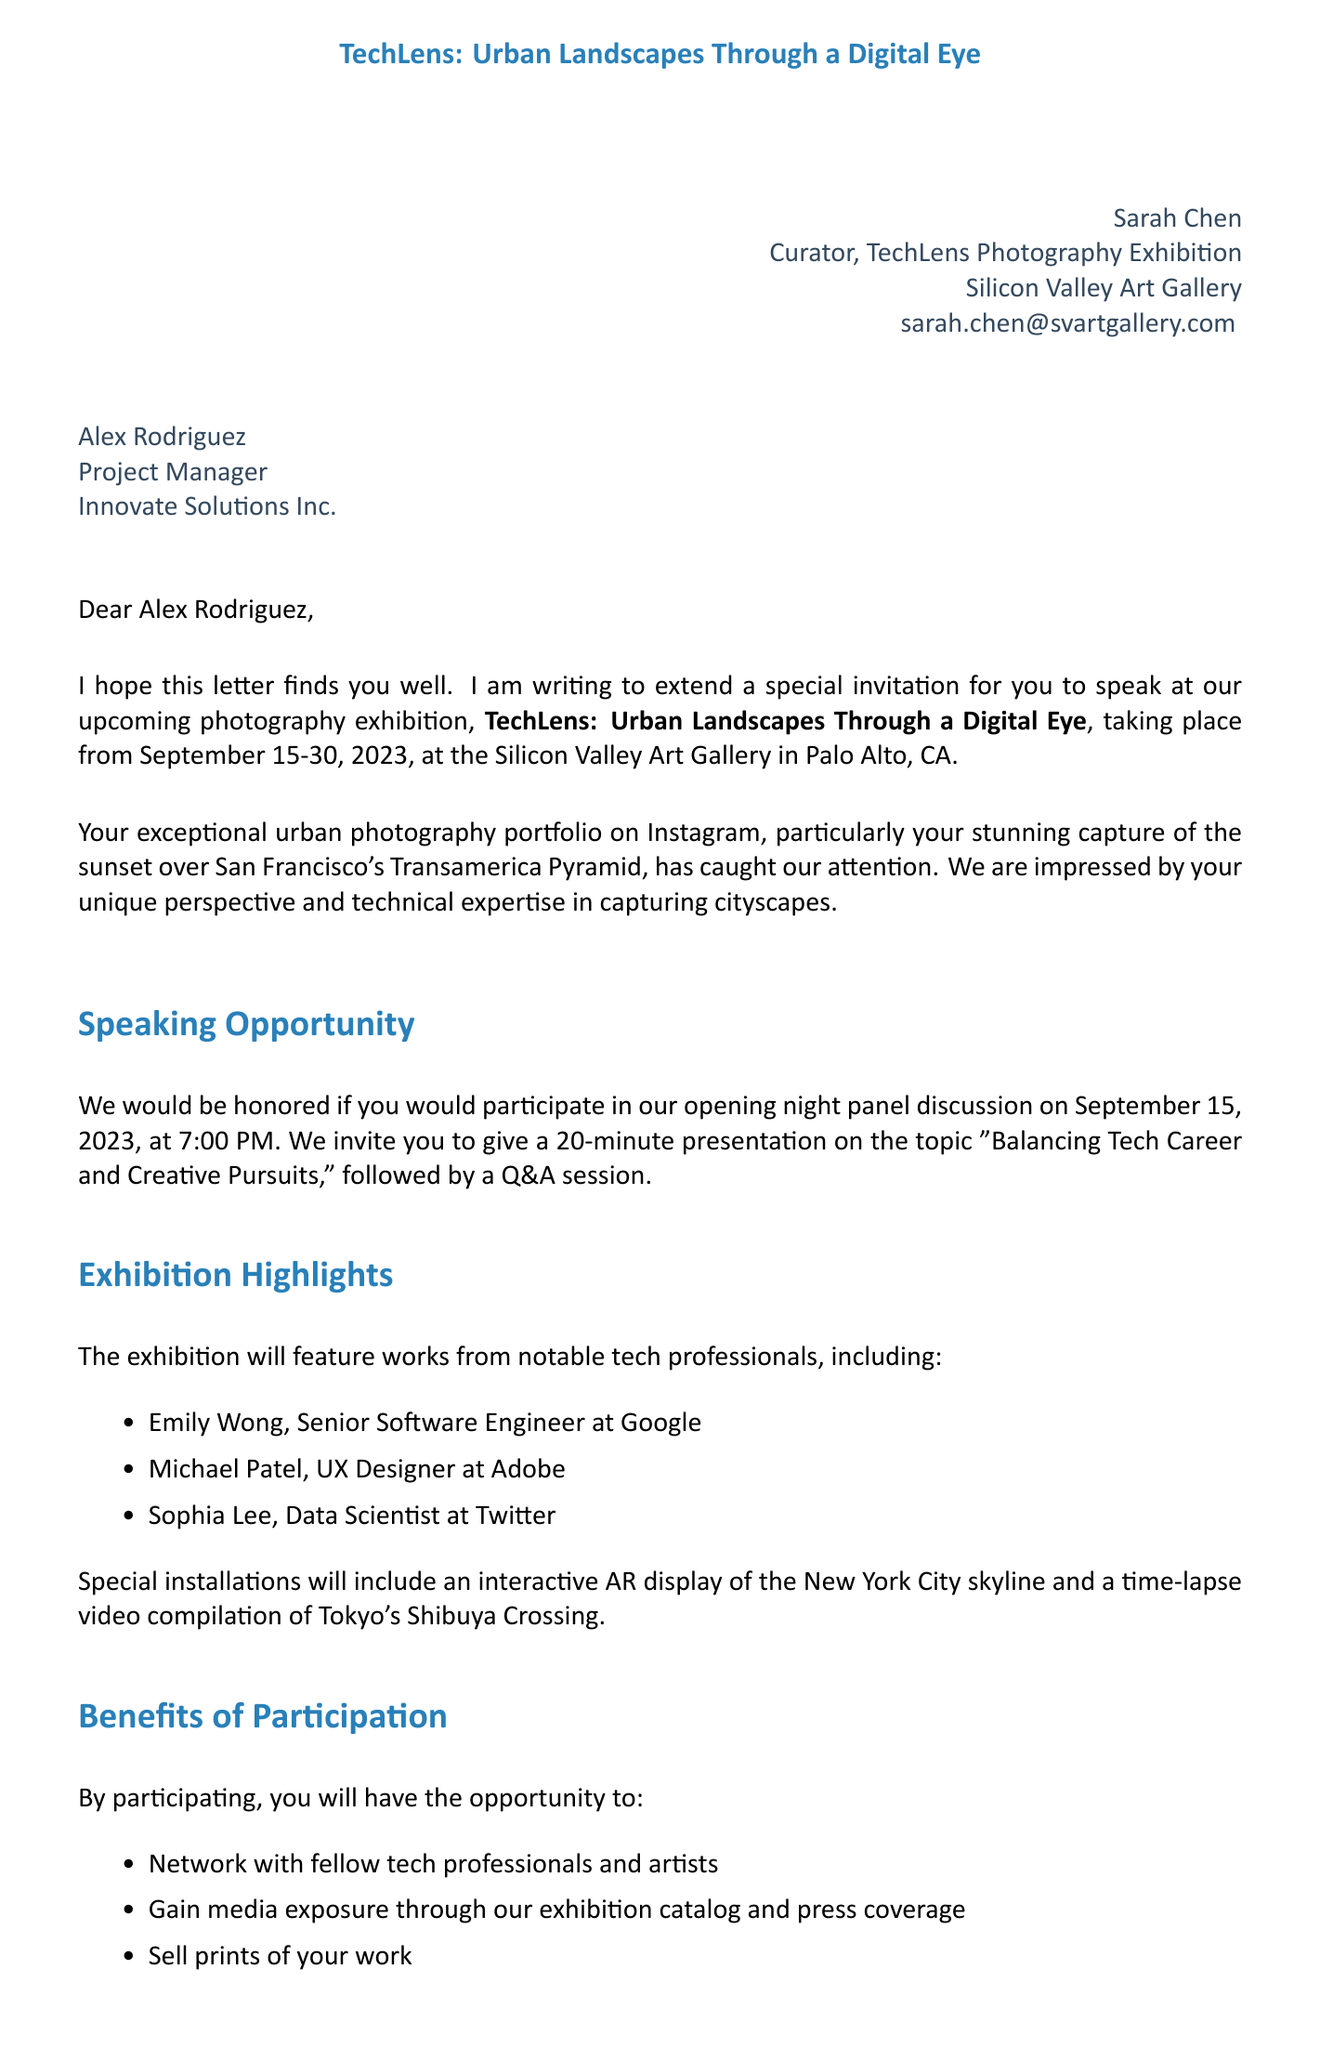what is the name of the exhibition? The name of the exhibition is mentioned in the document as "TechLens: Urban Landscapes Through a Digital Eye."
Answer: TechLens: Urban Landscapes Through a Digital Eye what are the exhibition dates? The document specifies the dates when the exhibition will take place, which are September 15-30, 2023.
Answer: September 15-30, 2023 who is the sender of the invitation? The sender's name and title are included at the beginning of the document, identifying them as Sarah Chen, Curator.
Answer: Sarah Chen what is the topic of the presentation? The document indicates that the presentation topic is outlined as "Balancing Tech Career and Creative Pursuits."
Answer: Balancing Tech Career and Creative Pursuits how many expected attendees will be present at the event? Information regarding the anticipated size of the audience is provided in the document, which states 200-250 attendees.
Answer: 200-250 attendees what special installation will be featured in the exhibition? The document lists special installations and one prominent example given is the "Interactive AR display of New York City skyline."
Answer: Interactive AR display of New York City skyline what is the deadline for responding to the invitation? The document specifies that a response is requested by a certain date, which is August 1, 2023.
Answer: August 1, 2023 what benefit includes media exposure? The document outlines multiple benefits of participation, particularly mentioning "gain media exposure through our exhibition catalog and press coverage."
Answer: gain media exposure through our exhibition catalog and press coverage what is provided for the presentation? The logistics section details what will be available for the presentation, specifically mentioning "high-quality projection system and microphone."
Answer: high-quality projection system and microphone 